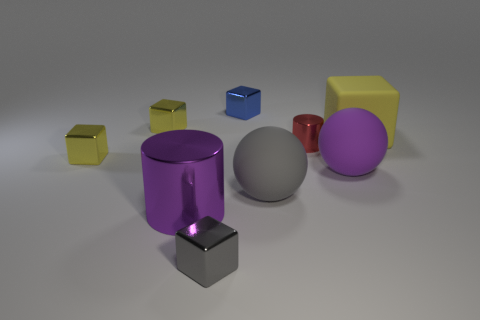How many yellow blocks must be subtracted to get 1 yellow blocks? 2 Subtract all purple cylinders. How many yellow blocks are left? 3 Subtract all tiny blue shiny blocks. How many blocks are left? 4 Subtract all gray cubes. How many cubes are left? 4 Subtract all cyan blocks. Subtract all brown spheres. How many blocks are left? 5 Add 1 purple things. How many objects exist? 10 Subtract all spheres. How many objects are left? 7 Subtract all big blue matte blocks. Subtract all small blue cubes. How many objects are left? 8 Add 2 red metallic cylinders. How many red metallic cylinders are left? 3 Add 7 gray metallic things. How many gray metallic things exist? 8 